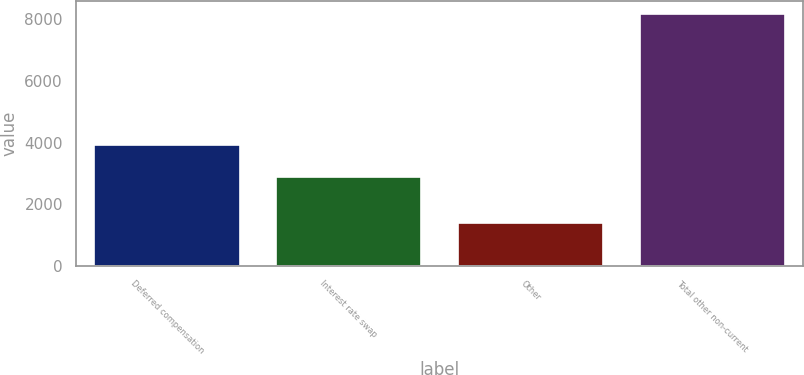Convert chart to OTSL. <chart><loc_0><loc_0><loc_500><loc_500><bar_chart><fcel>Deferred compensation<fcel>Interest rate swap<fcel>Other<fcel>Total other non-current<nl><fcel>3915<fcel>2886<fcel>1377<fcel>8178<nl></chart> 